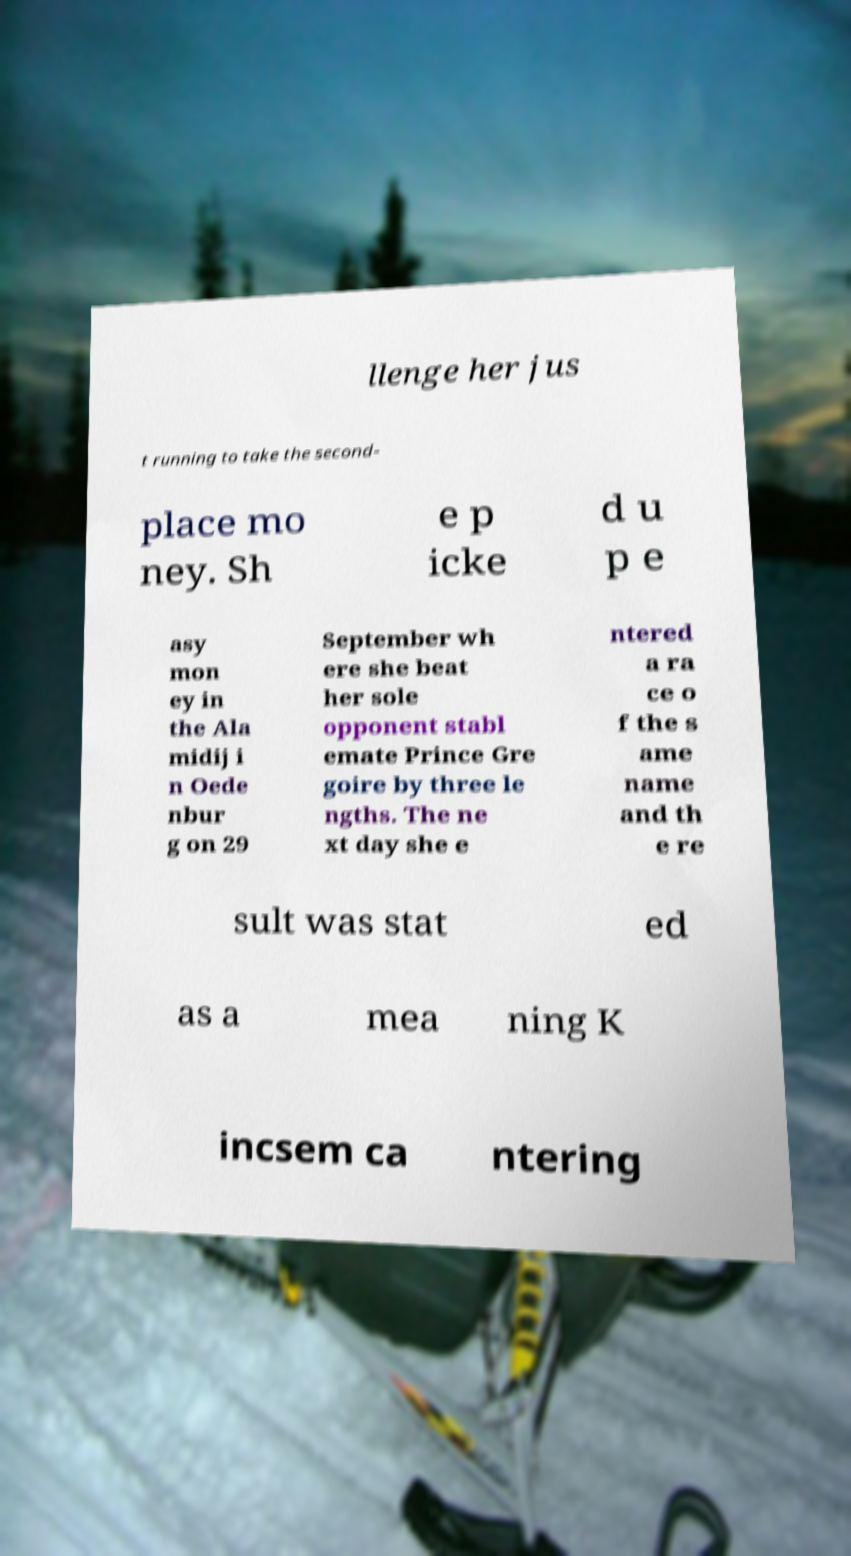For documentation purposes, I need the text within this image transcribed. Could you provide that? llenge her jus t running to take the second- place mo ney. Sh e p icke d u p e asy mon ey in the Ala midij i n Oede nbur g on 29 September wh ere she beat her sole opponent stabl emate Prince Gre goire by three le ngths. The ne xt day she e ntered a ra ce o f the s ame name and th e re sult was stat ed as a mea ning K incsem ca ntering 